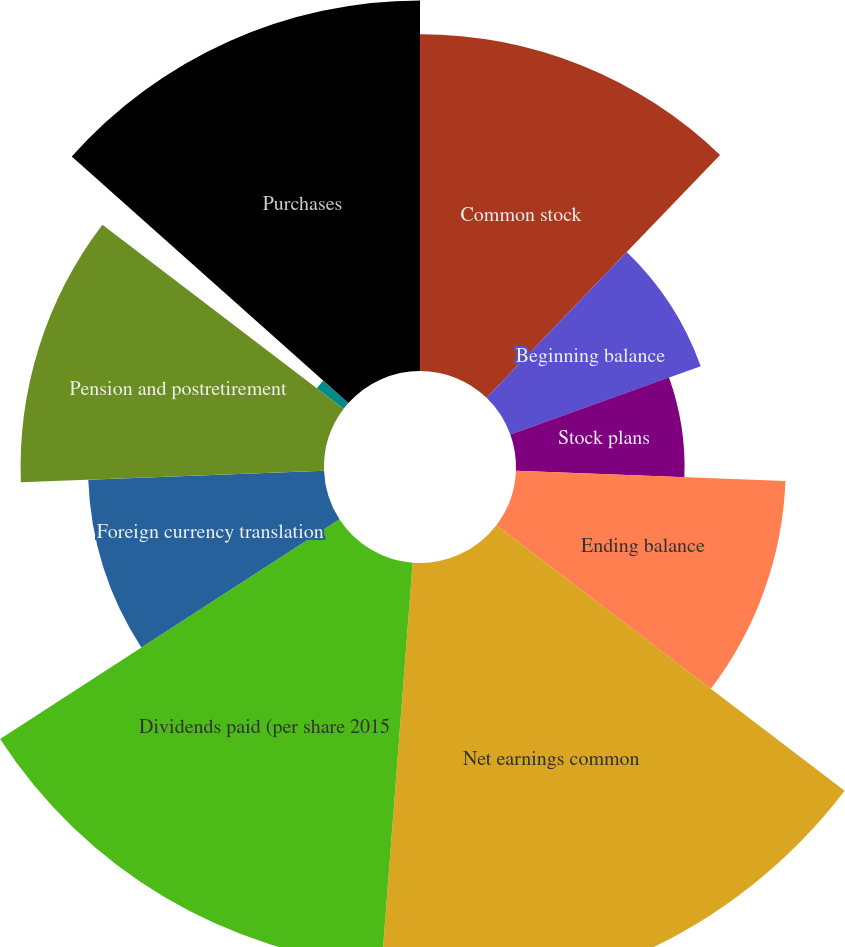<chart> <loc_0><loc_0><loc_500><loc_500><pie_chart><fcel>Common stock<fcel>Beginning balance<fcel>Stock plans<fcel>Ending balance<fcel>Net earnings common<fcel>Dividends paid (per share 2015<fcel>Foreign currency translation<fcel>Pension and postretirement<fcel>Cash flow hedges<fcel>Purchases<nl><fcel>12.19%<fcel>7.32%<fcel>6.1%<fcel>9.76%<fcel>15.85%<fcel>14.63%<fcel>8.54%<fcel>10.98%<fcel>1.22%<fcel>13.41%<nl></chart> 